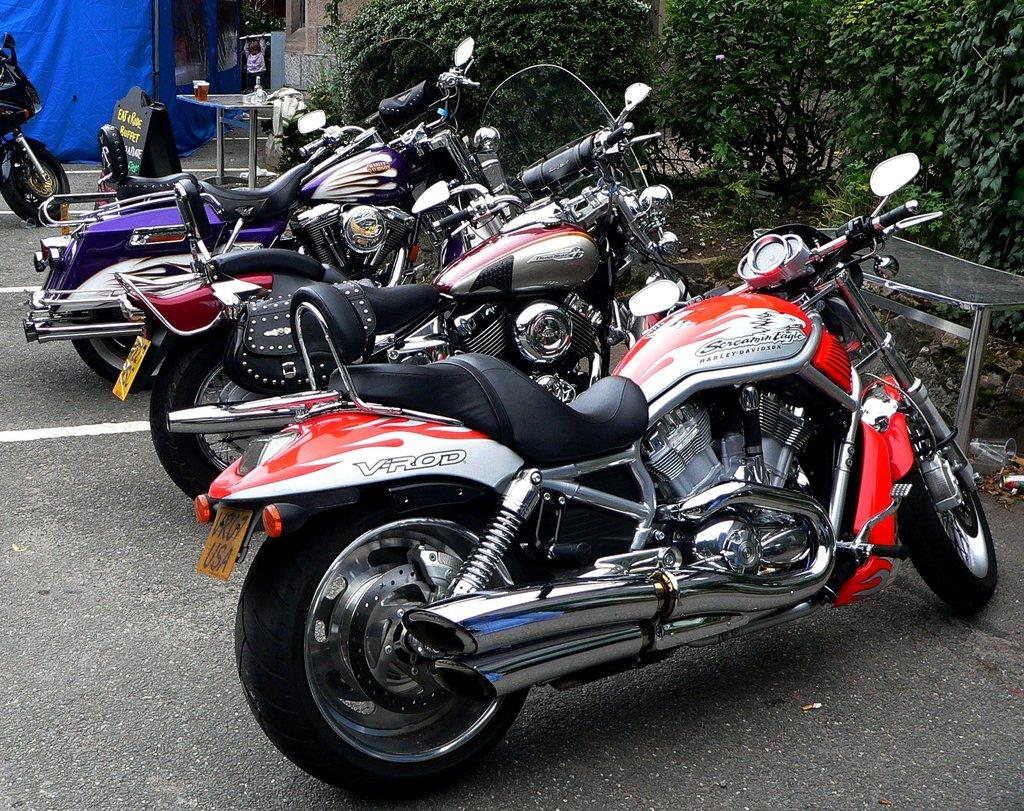What types of objects can be seen in the image? There are vehicles, tables with objects, and a blue colored cloth in the image. What can be seen on the ground in the image? The ground is visible in the image. Are there any plants present in the image? Yes, there are plants in the image. What type of stamp can be seen on the blue cloth in the image? There is no stamp present on the blue cloth in the image. How many rings are visible on the vehicles in the image? There are no rings visible on the vehicles in the image. 